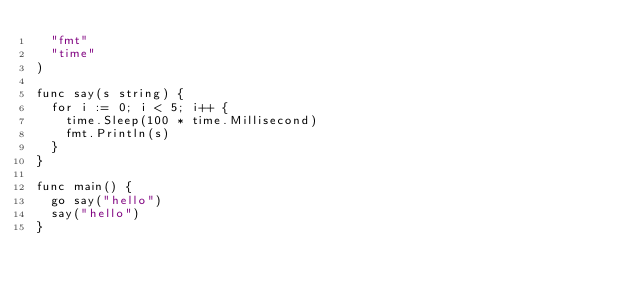Convert code to text. <code><loc_0><loc_0><loc_500><loc_500><_Go_>	"fmt"
	"time"
)

func say(s string) {
	for i := 0; i < 5; i++ {
		time.Sleep(100 * time.Millisecond)
		fmt.Println(s)
	}
}

func main() {
	go say("hello")
	say("hello")
}
</code> 